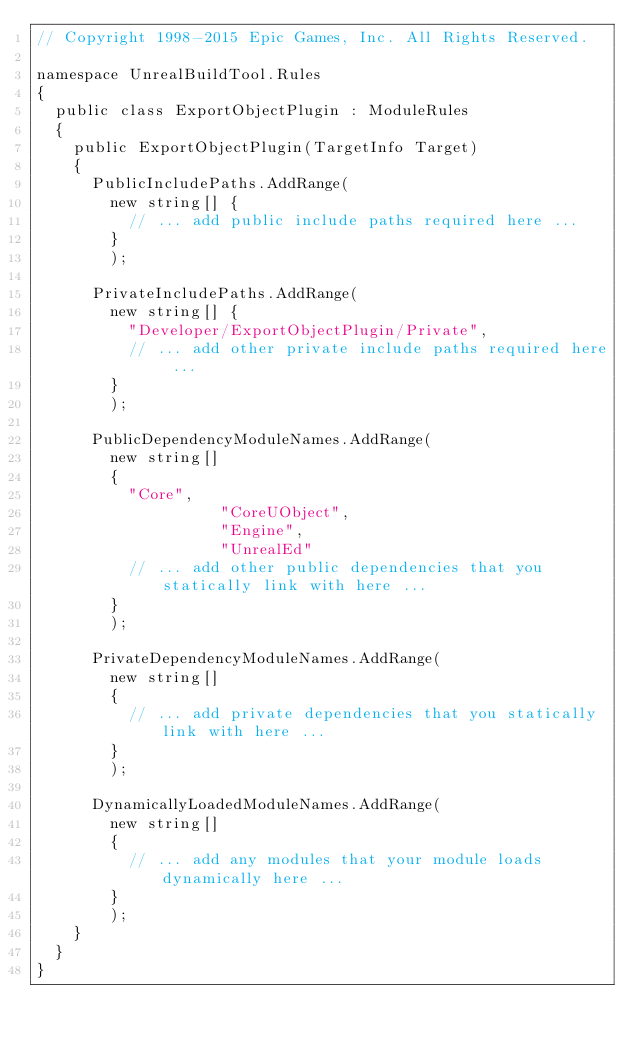<code> <loc_0><loc_0><loc_500><loc_500><_C#_>// Copyright 1998-2015 Epic Games, Inc. All Rights Reserved.

namespace UnrealBuildTool.Rules
{
	public class ExportObjectPlugin : ModuleRules
	{
		public ExportObjectPlugin(TargetInfo Target)
		{
			PublicIncludePaths.AddRange(
				new string[] {
					// ... add public include paths required here ...
				}
				);

			PrivateIncludePaths.AddRange(
				new string[] {
					"Developer/ExportObjectPlugin/Private",
					// ... add other private include paths required here ...
				}
				);

			PublicDependencyModuleNames.AddRange(
				new string[]
				{
					"Core",
                    "CoreUObject",
                    "Engine",
                    "UnrealEd"
					// ... add other public dependencies that you statically link with here ...
				}
				);

			PrivateDependencyModuleNames.AddRange(
				new string[]
				{
					// ... add private dependencies that you statically link with here ...
				}
				);

			DynamicallyLoadedModuleNames.AddRange(
				new string[]
				{
					// ... add any modules that your module loads dynamically here ...
				}
				);
		}
	}
}</code> 